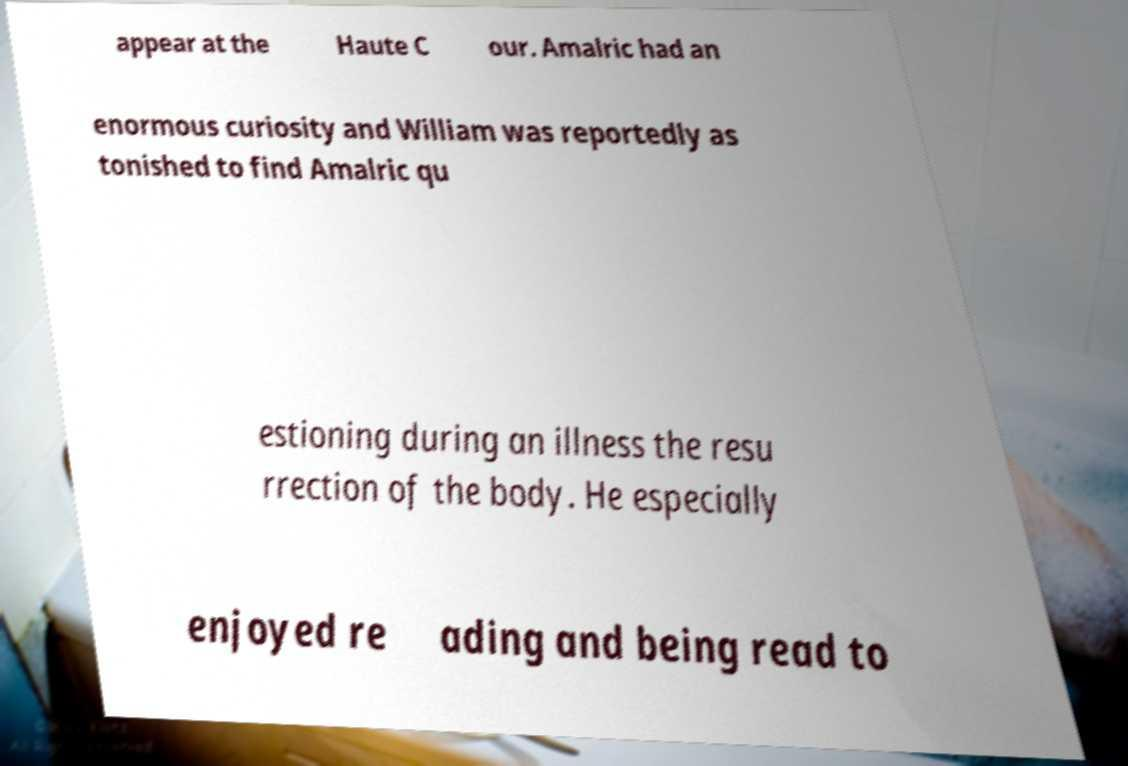Can you accurately transcribe the text from the provided image for me? appear at the Haute C our. Amalric had an enormous curiosity and William was reportedly as tonished to find Amalric qu estioning during an illness the resu rrection of the body. He especially enjoyed re ading and being read to 